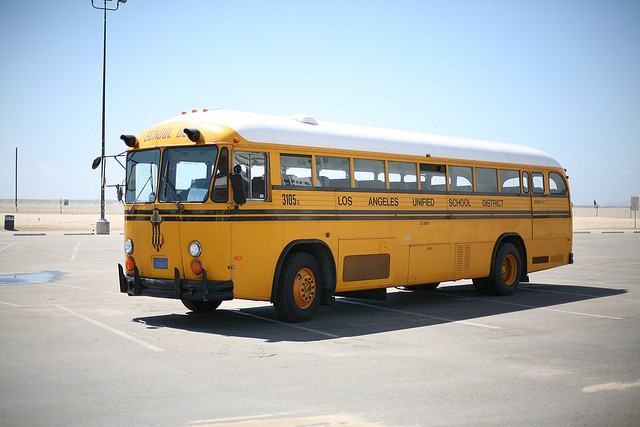<image>What is directly behind the back of the bus? It is unknown what is directly behind the back of the bus. It could be a light post, a parking lot, a post, the beach or pavement. What is directly behind the back of the bus? I don't know what is directly behind the back of the bus. It can be anything, such as a light post, parking lot, beach, or nothing at all. 